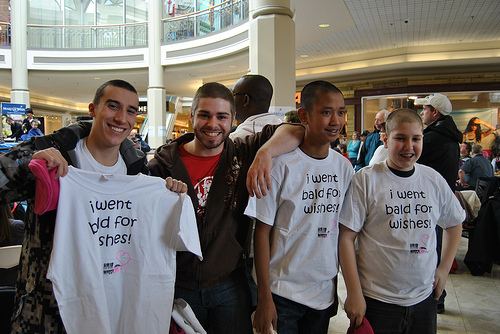<image>
Is the boy on the boy? No. The boy is not positioned on the boy. They may be near each other, but the boy is not supported by or resting on top of the boy. 